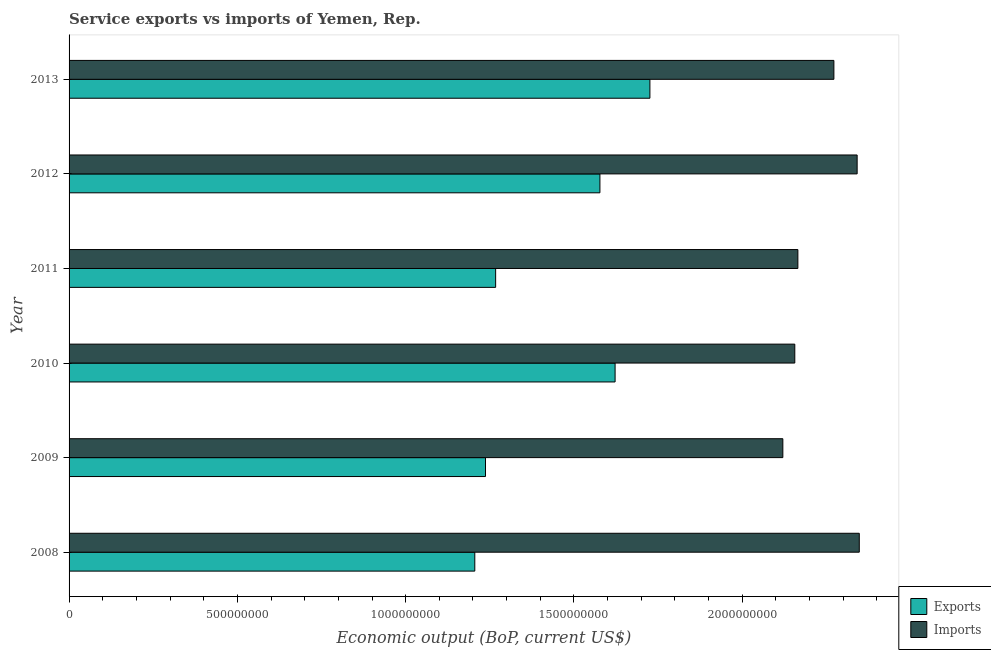How many groups of bars are there?
Provide a short and direct response. 6. Are the number of bars per tick equal to the number of legend labels?
Your response must be concise. Yes. Are the number of bars on each tick of the Y-axis equal?
Your answer should be compact. Yes. In how many cases, is the number of bars for a given year not equal to the number of legend labels?
Your response must be concise. 0. What is the amount of service imports in 2013?
Give a very brief answer. 2.27e+09. Across all years, what is the maximum amount of service imports?
Your answer should be very brief. 2.35e+09. Across all years, what is the minimum amount of service imports?
Offer a terse response. 2.12e+09. In which year was the amount of service exports maximum?
Keep it short and to the point. 2013. In which year was the amount of service exports minimum?
Keep it short and to the point. 2008. What is the total amount of service imports in the graph?
Offer a very short reply. 1.34e+1. What is the difference between the amount of service exports in 2011 and that in 2012?
Offer a very short reply. -3.10e+08. What is the difference between the amount of service imports in 2012 and the amount of service exports in 2013?
Ensure brevity in your answer.  6.16e+08. What is the average amount of service imports per year?
Offer a very short reply. 2.23e+09. In the year 2009, what is the difference between the amount of service exports and amount of service imports?
Ensure brevity in your answer.  -8.83e+08. In how many years, is the amount of service exports greater than 800000000 US$?
Your response must be concise. 6. What is the ratio of the amount of service imports in 2012 to that in 2013?
Give a very brief answer. 1.03. Is the difference between the amount of service imports in 2011 and 2012 greater than the difference between the amount of service exports in 2011 and 2012?
Keep it short and to the point. Yes. What is the difference between the highest and the second highest amount of service imports?
Your answer should be very brief. 6.34e+06. What is the difference between the highest and the lowest amount of service exports?
Provide a short and direct response. 5.20e+08. In how many years, is the amount of service exports greater than the average amount of service exports taken over all years?
Your answer should be compact. 3. What does the 2nd bar from the top in 2010 represents?
Your response must be concise. Exports. What does the 2nd bar from the bottom in 2012 represents?
Your answer should be very brief. Imports. How many bars are there?
Provide a short and direct response. 12. How many years are there in the graph?
Give a very brief answer. 6. Are the values on the major ticks of X-axis written in scientific E-notation?
Make the answer very short. No. Does the graph contain any zero values?
Make the answer very short. No. Does the graph contain grids?
Ensure brevity in your answer.  No. Where does the legend appear in the graph?
Make the answer very short. Bottom right. What is the title of the graph?
Provide a succinct answer. Service exports vs imports of Yemen, Rep. Does "Manufacturing industries and construction" appear as one of the legend labels in the graph?
Provide a short and direct response. No. What is the label or title of the X-axis?
Your answer should be compact. Economic output (BoP, current US$). What is the label or title of the Y-axis?
Provide a short and direct response. Year. What is the Economic output (BoP, current US$) of Exports in 2008?
Your answer should be very brief. 1.21e+09. What is the Economic output (BoP, current US$) in Imports in 2008?
Offer a terse response. 2.35e+09. What is the Economic output (BoP, current US$) in Exports in 2009?
Give a very brief answer. 1.24e+09. What is the Economic output (BoP, current US$) in Imports in 2009?
Ensure brevity in your answer.  2.12e+09. What is the Economic output (BoP, current US$) of Exports in 2010?
Provide a succinct answer. 1.62e+09. What is the Economic output (BoP, current US$) in Imports in 2010?
Keep it short and to the point. 2.16e+09. What is the Economic output (BoP, current US$) in Exports in 2011?
Ensure brevity in your answer.  1.27e+09. What is the Economic output (BoP, current US$) of Imports in 2011?
Offer a very short reply. 2.17e+09. What is the Economic output (BoP, current US$) in Exports in 2012?
Give a very brief answer. 1.58e+09. What is the Economic output (BoP, current US$) of Imports in 2012?
Your answer should be compact. 2.34e+09. What is the Economic output (BoP, current US$) in Exports in 2013?
Provide a short and direct response. 1.73e+09. What is the Economic output (BoP, current US$) in Imports in 2013?
Give a very brief answer. 2.27e+09. Across all years, what is the maximum Economic output (BoP, current US$) in Exports?
Provide a succinct answer. 1.73e+09. Across all years, what is the maximum Economic output (BoP, current US$) in Imports?
Provide a succinct answer. 2.35e+09. Across all years, what is the minimum Economic output (BoP, current US$) in Exports?
Make the answer very short. 1.21e+09. Across all years, what is the minimum Economic output (BoP, current US$) of Imports?
Ensure brevity in your answer.  2.12e+09. What is the total Economic output (BoP, current US$) in Exports in the graph?
Provide a succinct answer. 8.63e+09. What is the total Economic output (BoP, current US$) of Imports in the graph?
Your answer should be compact. 1.34e+1. What is the difference between the Economic output (BoP, current US$) of Exports in 2008 and that in 2009?
Provide a succinct answer. -3.18e+07. What is the difference between the Economic output (BoP, current US$) of Imports in 2008 and that in 2009?
Offer a very short reply. 2.27e+08. What is the difference between the Economic output (BoP, current US$) of Exports in 2008 and that in 2010?
Offer a terse response. -4.17e+08. What is the difference between the Economic output (BoP, current US$) in Imports in 2008 and that in 2010?
Your answer should be very brief. 1.92e+08. What is the difference between the Economic output (BoP, current US$) of Exports in 2008 and that in 2011?
Offer a terse response. -6.19e+07. What is the difference between the Economic output (BoP, current US$) in Imports in 2008 and that in 2011?
Offer a very short reply. 1.82e+08. What is the difference between the Economic output (BoP, current US$) of Exports in 2008 and that in 2012?
Give a very brief answer. -3.72e+08. What is the difference between the Economic output (BoP, current US$) of Imports in 2008 and that in 2012?
Your answer should be very brief. 6.34e+06. What is the difference between the Economic output (BoP, current US$) of Exports in 2008 and that in 2013?
Give a very brief answer. -5.20e+08. What is the difference between the Economic output (BoP, current US$) in Imports in 2008 and that in 2013?
Provide a short and direct response. 7.54e+07. What is the difference between the Economic output (BoP, current US$) in Exports in 2009 and that in 2010?
Ensure brevity in your answer.  -3.85e+08. What is the difference between the Economic output (BoP, current US$) of Imports in 2009 and that in 2010?
Your answer should be very brief. -3.55e+07. What is the difference between the Economic output (BoP, current US$) in Exports in 2009 and that in 2011?
Offer a very short reply. -3.02e+07. What is the difference between the Economic output (BoP, current US$) in Imports in 2009 and that in 2011?
Your answer should be very brief. -4.47e+07. What is the difference between the Economic output (BoP, current US$) of Exports in 2009 and that in 2012?
Keep it short and to the point. -3.40e+08. What is the difference between the Economic output (BoP, current US$) in Imports in 2009 and that in 2012?
Make the answer very short. -2.21e+08. What is the difference between the Economic output (BoP, current US$) in Exports in 2009 and that in 2013?
Provide a succinct answer. -4.88e+08. What is the difference between the Economic output (BoP, current US$) of Imports in 2009 and that in 2013?
Ensure brevity in your answer.  -1.52e+08. What is the difference between the Economic output (BoP, current US$) in Exports in 2010 and that in 2011?
Offer a terse response. 3.55e+08. What is the difference between the Economic output (BoP, current US$) in Imports in 2010 and that in 2011?
Provide a succinct answer. -9.16e+06. What is the difference between the Economic output (BoP, current US$) of Exports in 2010 and that in 2012?
Your response must be concise. 4.51e+07. What is the difference between the Economic output (BoP, current US$) in Imports in 2010 and that in 2012?
Give a very brief answer. -1.85e+08. What is the difference between the Economic output (BoP, current US$) in Exports in 2010 and that in 2013?
Your answer should be compact. -1.03e+08. What is the difference between the Economic output (BoP, current US$) in Imports in 2010 and that in 2013?
Your answer should be compact. -1.16e+08. What is the difference between the Economic output (BoP, current US$) in Exports in 2011 and that in 2012?
Keep it short and to the point. -3.10e+08. What is the difference between the Economic output (BoP, current US$) of Imports in 2011 and that in 2012?
Your answer should be very brief. -1.76e+08. What is the difference between the Economic output (BoP, current US$) of Exports in 2011 and that in 2013?
Give a very brief answer. -4.58e+08. What is the difference between the Economic output (BoP, current US$) in Imports in 2011 and that in 2013?
Provide a succinct answer. -1.07e+08. What is the difference between the Economic output (BoP, current US$) in Exports in 2012 and that in 2013?
Offer a terse response. -1.48e+08. What is the difference between the Economic output (BoP, current US$) of Imports in 2012 and that in 2013?
Provide a short and direct response. 6.91e+07. What is the difference between the Economic output (BoP, current US$) of Exports in 2008 and the Economic output (BoP, current US$) of Imports in 2009?
Keep it short and to the point. -9.15e+08. What is the difference between the Economic output (BoP, current US$) in Exports in 2008 and the Economic output (BoP, current US$) in Imports in 2010?
Provide a short and direct response. -9.51e+08. What is the difference between the Economic output (BoP, current US$) in Exports in 2008 and the Economic output (BoP, current US$) in Imports in 2011?
Your answer should be compact. -9.60e+08. What is the difference between the Economic output (BoP, current US$) of Exports in 2008 and the Economic output (BoP, current US$) of Imports in 2012?
Give a very brief answer. -1.14e+09. What is the difference between the Economic output (BoP, current US$) in Exports in 2008 and the Economic output (BoP, current US$) in Imports in 2013?
Your response must be concise. -1.07e+09. What is the difference between the Economic output (BoP, current US$) in Exports in 2009 and the Economic output (BoP, current US$) in Imports in 2010?
Offer a very short reply. -9.19e+08. What is the difference between the Economic output (BoP, current US$) of Exports in 2009 and the Economic output (BoP, current US$) of Imports in 2011?
Provide a short and direct response. -9.28e+08. What is the difference between the Economic output (BoP, current US$) in Exports in 2009 and the Economic output (BoP, current US$) in Imports in 2012?
Ensure brevity in your answer.  -1.10e+09. What is the difference between the Economic output (BoP, current US$) of Exports in 2009 and the Economic output (BoP, current US$) of Imports in 2013?
Your answer should be compact. -1.04e+09. What is the difference between the Economic output (BoP, current US$) of Exports in 2010 and the Economic output (BoP, current US$) of Imports in 2011?
Make the answer very short. -5.43e+08. What is the difference between the Economic output (BoP, current US$) of Exports in 2010 and the Economic output (BoP, current US$) of Imports in 2012?
Give a very brief answer. -7.19e+08. What is the difference between the Economic output (BoP, current US$) in Exports in 2010 and the Economic output (BoP, current US$) in Imports in 2013?
Offer a very short reply. -6.50e+08. What is the difference between the Economic output (BoP, current US$) of Exports in 2011 and the Economic output (BoP, current US$) of Imports in 2012?
Provide a succinct answer. -1.07e+09. What is the difference between the Economic output (BoP, current US$) of Exports in 2011 and the Economic output (BoP, current US$) of Imports in 2013?
Provide a succinct answer. -1.00e+09. What is the difference between the Economic output (BoP, current US$) in Exports in 2012 and the Economic output (BoP, current US$) in Imports in 2013?
Give a very brief answer. -6.95e+08. What is the average Economic output (BoP, current US$) in Exports per year?
Your answer should be very brief. 1.44e+09. What is the average Economic output (BoP, current US$) of Imports per year?
Make the answer very short. 2.23e+09. In the year 2008, what is the difference between the Economic output (BoP, current US$) of Exports and Economic output (BoP, current US$) of Imports?
Provide a short and direct response. -1.14e+09. In the year 2009, what is the difference between the Economic output (BoP, current US$) of Exports and Economic output (BoP, current US$) of Imports?
Ensure brevity in your answer.  -8.83e+08. In the year 2010, what is the difference between the Economic output (BoP, current US$) of Exports and Economic output (BoP, current US$) of Imports?
Offer a terse response. -5.34e+08. In the year 2011, what is the difference between the Economic output (BoP, current US$) of Exports and Economic output (BoP, current US$) of Imports?
Ensure brevity in your answer.  -8.98e+08. In the year 2012, what is the difference between the Economic output (BoP, current US$) of Exports and Economic output (BoP, current US$) of Imports?
Provide a succinct answer. -7.64e+08. In the year 2013, what is the difference between the Economic output (BoP, current US$) of Exports and Economic output (BoP, current US$) of Imports?
Your answer should be very brief. -5.47e+08. What is the ratio of the Economic output (BoP, current US$) of Exports in 2008 to that in 2009?
Make the answer very short. 0.97. What is the ratio of the Economic output (BoP, current US$) of Imports in 2008 to that in 2009?
Give a very brief answer. 1.11. What is the ratio of the Economic output (BoP, current US$) in Exports in 2008 to that in 2010?
Offer a terse response. 0.74. What is the ratio of the Economic output (BoP, current US$) in Imports in 2008 to that in 2010?
Ensure brevity in your answer.  1.09. What is the ratio of the Economic output (BoP, current US$) of Exports in 2008 to that in 2011?
Your answer should be very brief. 0.95. What is the ratio of the Economic output (BoP, current US$) in Imports in 2008 to that in 2011?
Your answer should be very brief. 1.08. What is the ratio of the Economic output (BoP, current US$) of Exports in 2008 to that in 2012?
Provide a succinct answer. 0.76. What is the ratio of the Economic output (BoP, current US$) of Imports in 2008 to that in 2012?
Provide a short and direct response. 1. What is the ratio of the Economic output (BoP, current US$) in Exports in 2008 to that in 2013?
Make the answer very short. 0.7. What is the ratio of the Economic output (BoP, current US$) of Imports in 2008 to that in 2013?
Offer a very short reply. 1.03. What is the ratio of the Economic output (BoP, current US$) of Exports in 2009 to that in 2010?
Your response must be concise. 0.76. What is the ratio of the Economic output (BoP, current US$) of Imports in 2009 to that in 2010?
Provide a short and direct response. 0.98. What is the ratio of the Economic output (BoP, current US$) in Exports in 2009 to that in 2011?
Keep it short and to the point. 0.98. What is the ratio of the Economic output (BoP, current US$) of Imports in 2009 to that in 2011?
Offer a very short reply. 0.98. What is the ratio of the Economic output (BoP, current US$) in Exports in 2009 to that in 2012?
Your answer should be very brief. 0.78. What is the ratio of the Economic output (BoP, current US$) in Imports in 2009 to that in 2012?
Ensure brevity in your answer.  0.91. What is the ratio of the Economic output (BoP, current US$) in Exports in 2009 to that in 2013?
Offer a very short reply. 0.72. What is the ratio of the Economic output (BoP, current US$) of Imports in 2009 to that in 2013?
Ensure brevity in your answer.  0.93. What is the ratio of the Economic output (BoP, current US$) in Exports in 2010 to that in 2011?
Provide a succinct answer. 1.28. What is the ratio of the Economic output (BoP, current US$) in Exports in 2010 to that in 2012?
Give a very brief answer. 1.03. What is the ratio of the Economic output (BoP, current US$) of Imports in 2010 to that in 2012?
Give a very brief answer. 0.92. What is the ratio of the Economic output (BoP, current US$) in Exports in 2010 to that in 2013?
Your response must be concise. 0.94. What is the ratio of the Economic output (BoP, current US$) in Imports in 2010 to that in 2013?
Your response must be concise. 0.95. What is the ratio of the Economic output (BoP, current US$) of Exports in 2011 to that in 2012?
Offer a terse response. 0.8. What is the ratio of the Economic output (BoP, current US$) in Imports in 2011 to that in 2012?
Your answer should be very brief. 0.92. What is the ratio of the Economic output (BoP, current US$) of Exports in 2011 to that in 2013?
Your response must be concise. 0.73. What is the ratio of the Economic output (BoP, current US$) of Imports in 2011 to that in 2013?
Keep it short and to the point. 0.95. What is the ratio of the Economic output (BoP, current US$) in Exports in 2012 to that in 2013?
Your answer should be compact. 0.91. What is the ratio of the Economic output (BoP, current US$) in Imports in 2012 to that in 2013?
Provide a short and direct response. 1.03. What is the difference between the highest and the second highest Economic output (BoP, current US$) in Exports?
Your response must be concise. 1.03e+08. What is the difference between the highest and the second highest Economic output (BoP, current US$) of Imports?
Provide a succinct answer. 6.34e+06. What is the difference between the highest and the lowest Economic output (BoP, current US$) of Exports?
Give a very brief answer. 5.20e+08. What is the difference between the highest and the lowest Economic output (BoP, current US$) in Imports?
Give a very brief answer. 2.27e+08. 